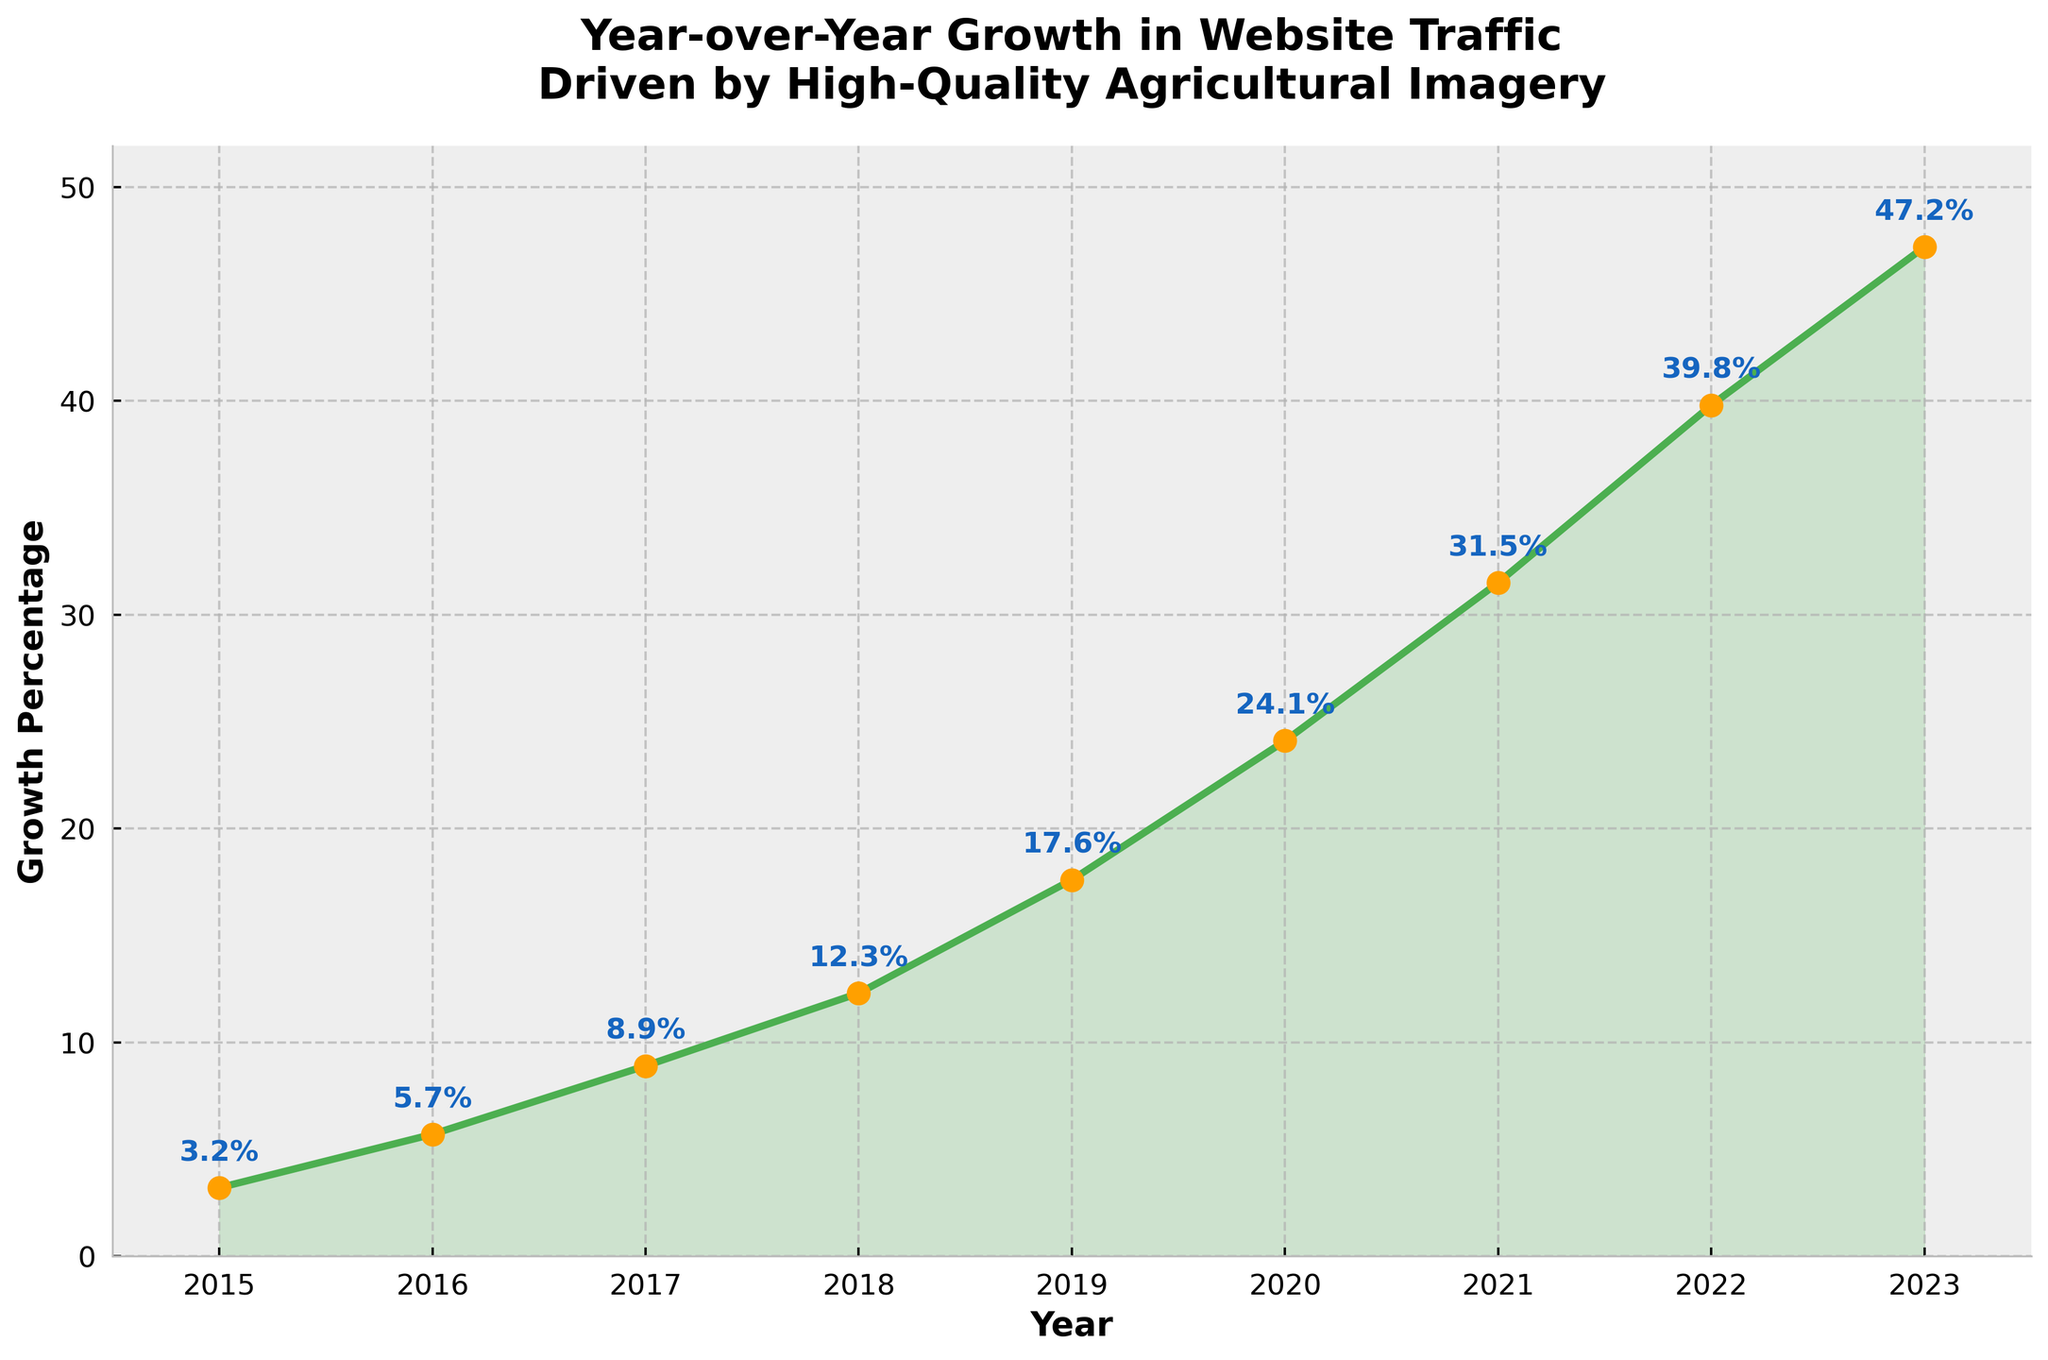What was the growth percentage in 2020? Locate the data point for the year 2020 and read the corresponding growth percentage.
Answer: 24.1% Across which years did the growth percentage increase by more than 10%? Analyze the growth percentage differences between consecutive years, selecting those with an increase greater than 10%. The increases can be seen in the transitions from 2018 to 2019 (5.3%) and from 2021 to 2022 (8.3%).
Answer: None What is the average growth percentage from 2015 to 2023? Sum all growth percentages from 2015 to 2023 and then divide by the number of years if we consider the entire span from 2015 to 2023, inclusive; the average is (3.2 + 5.7 + 8.9 + 12.3 + 17.6 + 24.1 + 31.5 + 39.8 + 47.2)/9 ≈ 21.145%.
Answer: 21.14% By how much did the growth percentage increase from 2019 to 2020? Subtract the 2019 growth percentage (17.6) from the 2020 growth percentage (24.1).
Answer: 6.5% Which year had the highest growth percentage, and what was the value? Identify the year with the highest percentage by comparing all data points in the plot.
Answer: 2023, 47.2% How does the growth percentage change visually from one year to the next? Observe the slope and direction of the line connecting consecutive data points. An increase creates an upward slope, and a decrease would create a downward slope.
Answer: Increasing every year What is the difference in growth percentage between 2016 and 2018? Subtract the growth percentage for 2016 (5.7) from that for 2018 (12.3).
Answer: 6.6% Identify the year with the highest slope of growth increase. Compare the slopes (steepness) of the lines connecting consecutive years and identify the steepest one, which corresponds to the greatest annual increase.
Answer: 2020 to 2021 What is the total growth percentage increase from 2015 to 2023? Subtract the 2015 growth percentage (3.2) from the 2023 growth percentage (47.2).
Answer: 44% What visual element indicates the exact growth percentages on the plot? Identify the markers used to annotate data points, which indicate the exact growth percentages.
Answer: Text annotations above each data point 